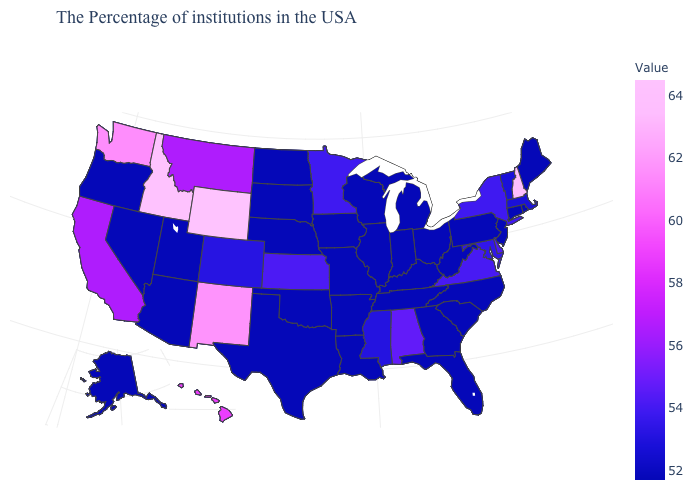Is the legend a continuous bar?
Give a very brief answer. Yes. Does the map have missing data?
Short answer required. No. Which states have the highest value in the USA?
Short answer required. Wyoming. Does Wyoming have the lowest value in the West?
Concise answer only. No. Among the states that border Arkansas , does Mississippi have the lowest value?
Concise answer only. No. 